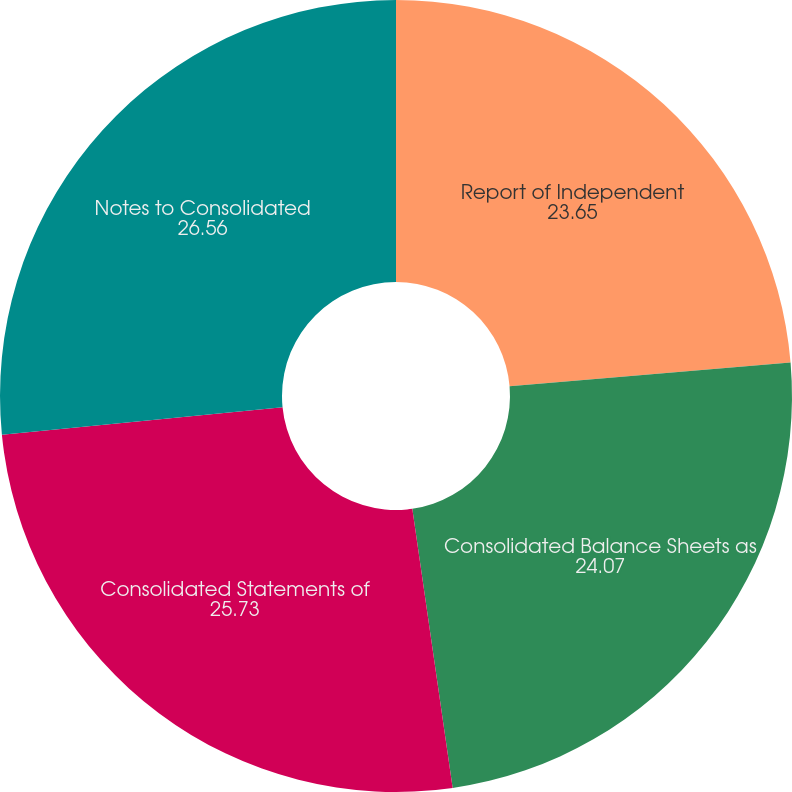Convert chart. <chart><loc_0><loc_0><loc_500><loc_500><pie_chart><fcel>Report of Independent<fcel>Consolidated Balance Sheets as<fcel>Consolidated Statements of<fcel>Notes to Consolidated<nl><fcel>23.65%<fcel>24.07%<fcel>25.73%<fcel>26.56%<nl></chart> 